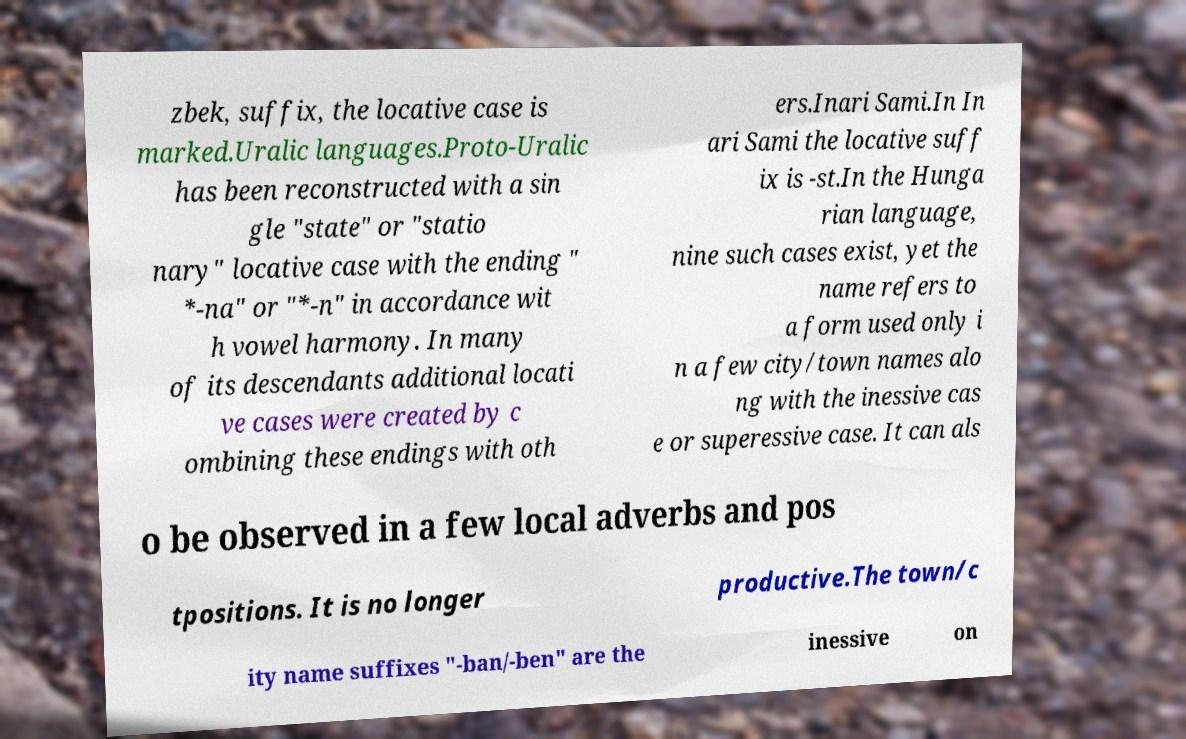Please identify and transcribe the text found in this image. zbek, suffix, the locative case is marked.Uralic languages.Proto-Uralic has been reconstructed with a sin gle "state" or "statio nary" locative case with the ending " *-na" or "*-n" in accordance wit h vowel harmony. In many of its descendants additional locati ve cases were created by c ombining these endings with oth ers.Inari Sami.In In ari Sami the locative suff ix is -st.In the Hunga rian language, nine such cases exist, yet the name refers to a form used only i n a few city/town names alo ng with the inessive cas e or superessive case. It can als o be observed in a few local adverbs and pos tpositions. It is no longer productive.The town/c ity name suffixes "-ban/-ben" are the inessive on 